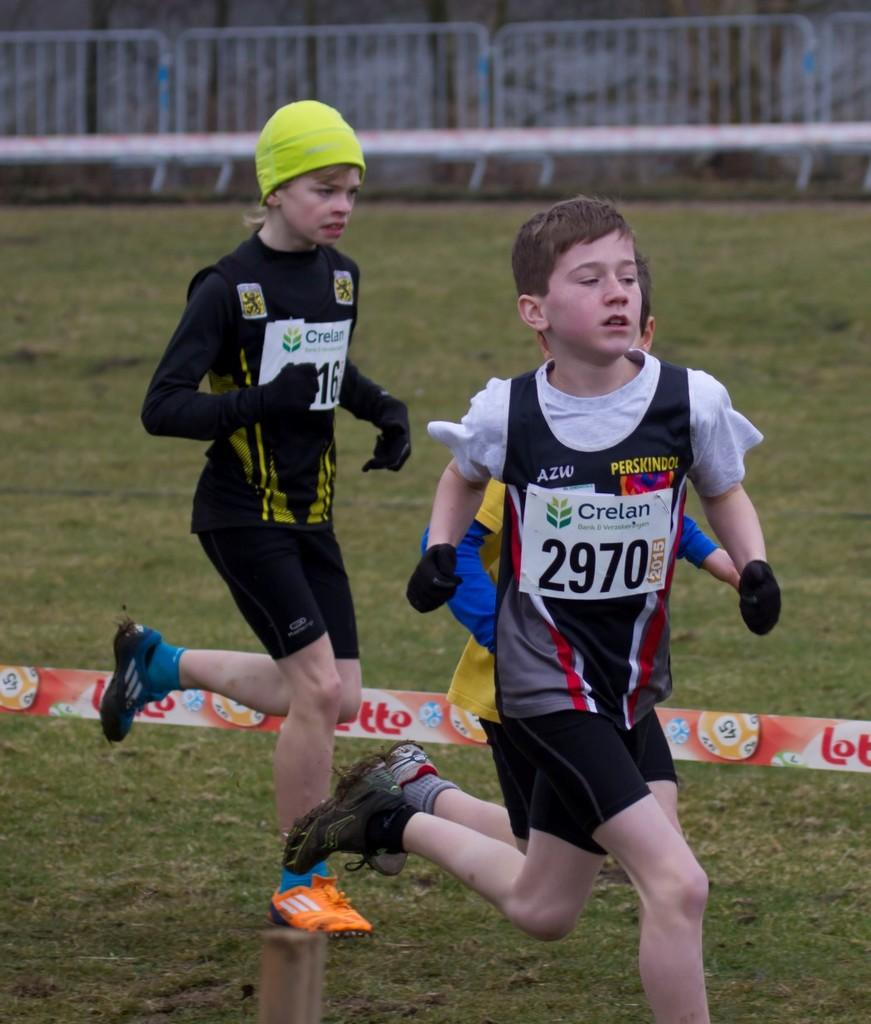What are the kids in the image doing? The kids are running in the center of the image. What can be seen hanging above the kids? There is a banner with text in the image. What type of surface are the kids running on? There is grass on the ground. What is visible in the background of the image? There is a fence in the background of the image. Are there any bells hanging from the fence in the image? There is no mention of bells in the image; only a fence is visible in the background. 